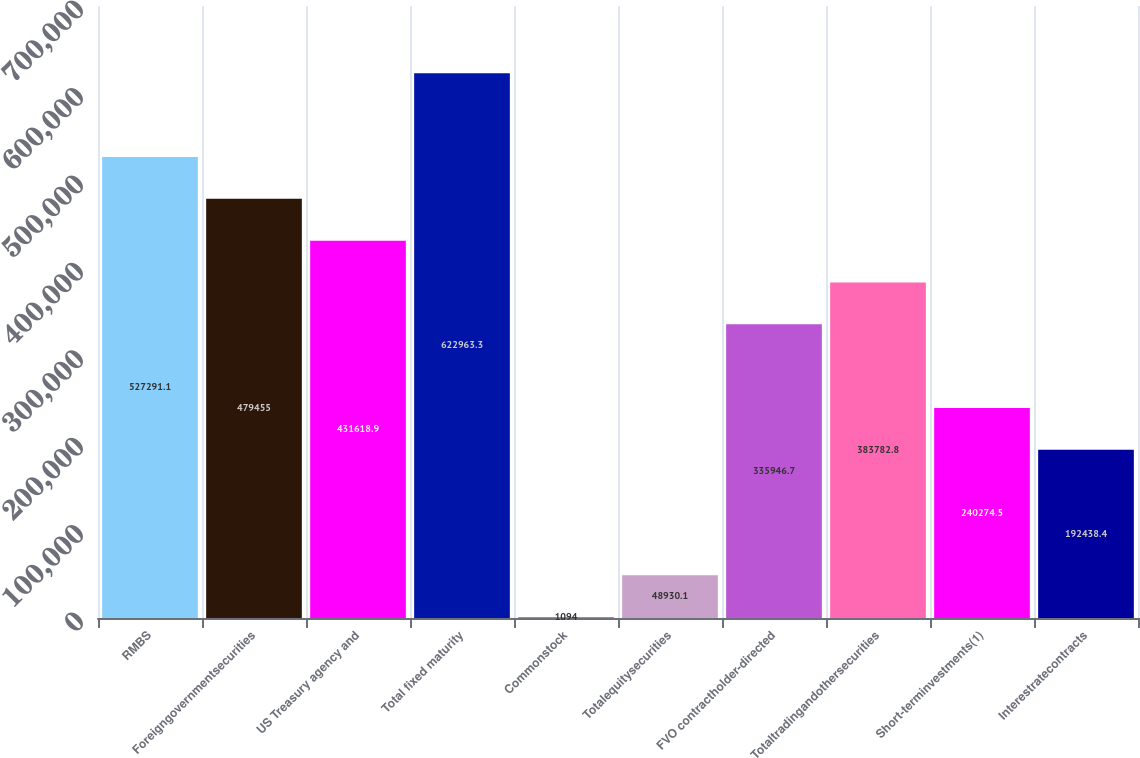Convert chart. <chart><loc_0><loc_0><loc_500><loc_500><bar_chart><fcel>RMBS<fcel>Foreigngovernmentsecurities<fcel>US Treasury agency and<fcel>Total fixed maturity<fcel>Commonstock<fcel>Totalequitysecurities<fcel>FVO contractholder-directed<fcel>Totaltradingandothersecurities<fcel>Short-terminvestments(1)<fcel>Interestratecontracts<nl><fcel>527291<fcel>479455<fcel>431619<fcel>622963<fcel>1094<fcel>48930.1<fcel>335947<fcel>383783<fcel>240274<fcel>192438<nl></chart> 